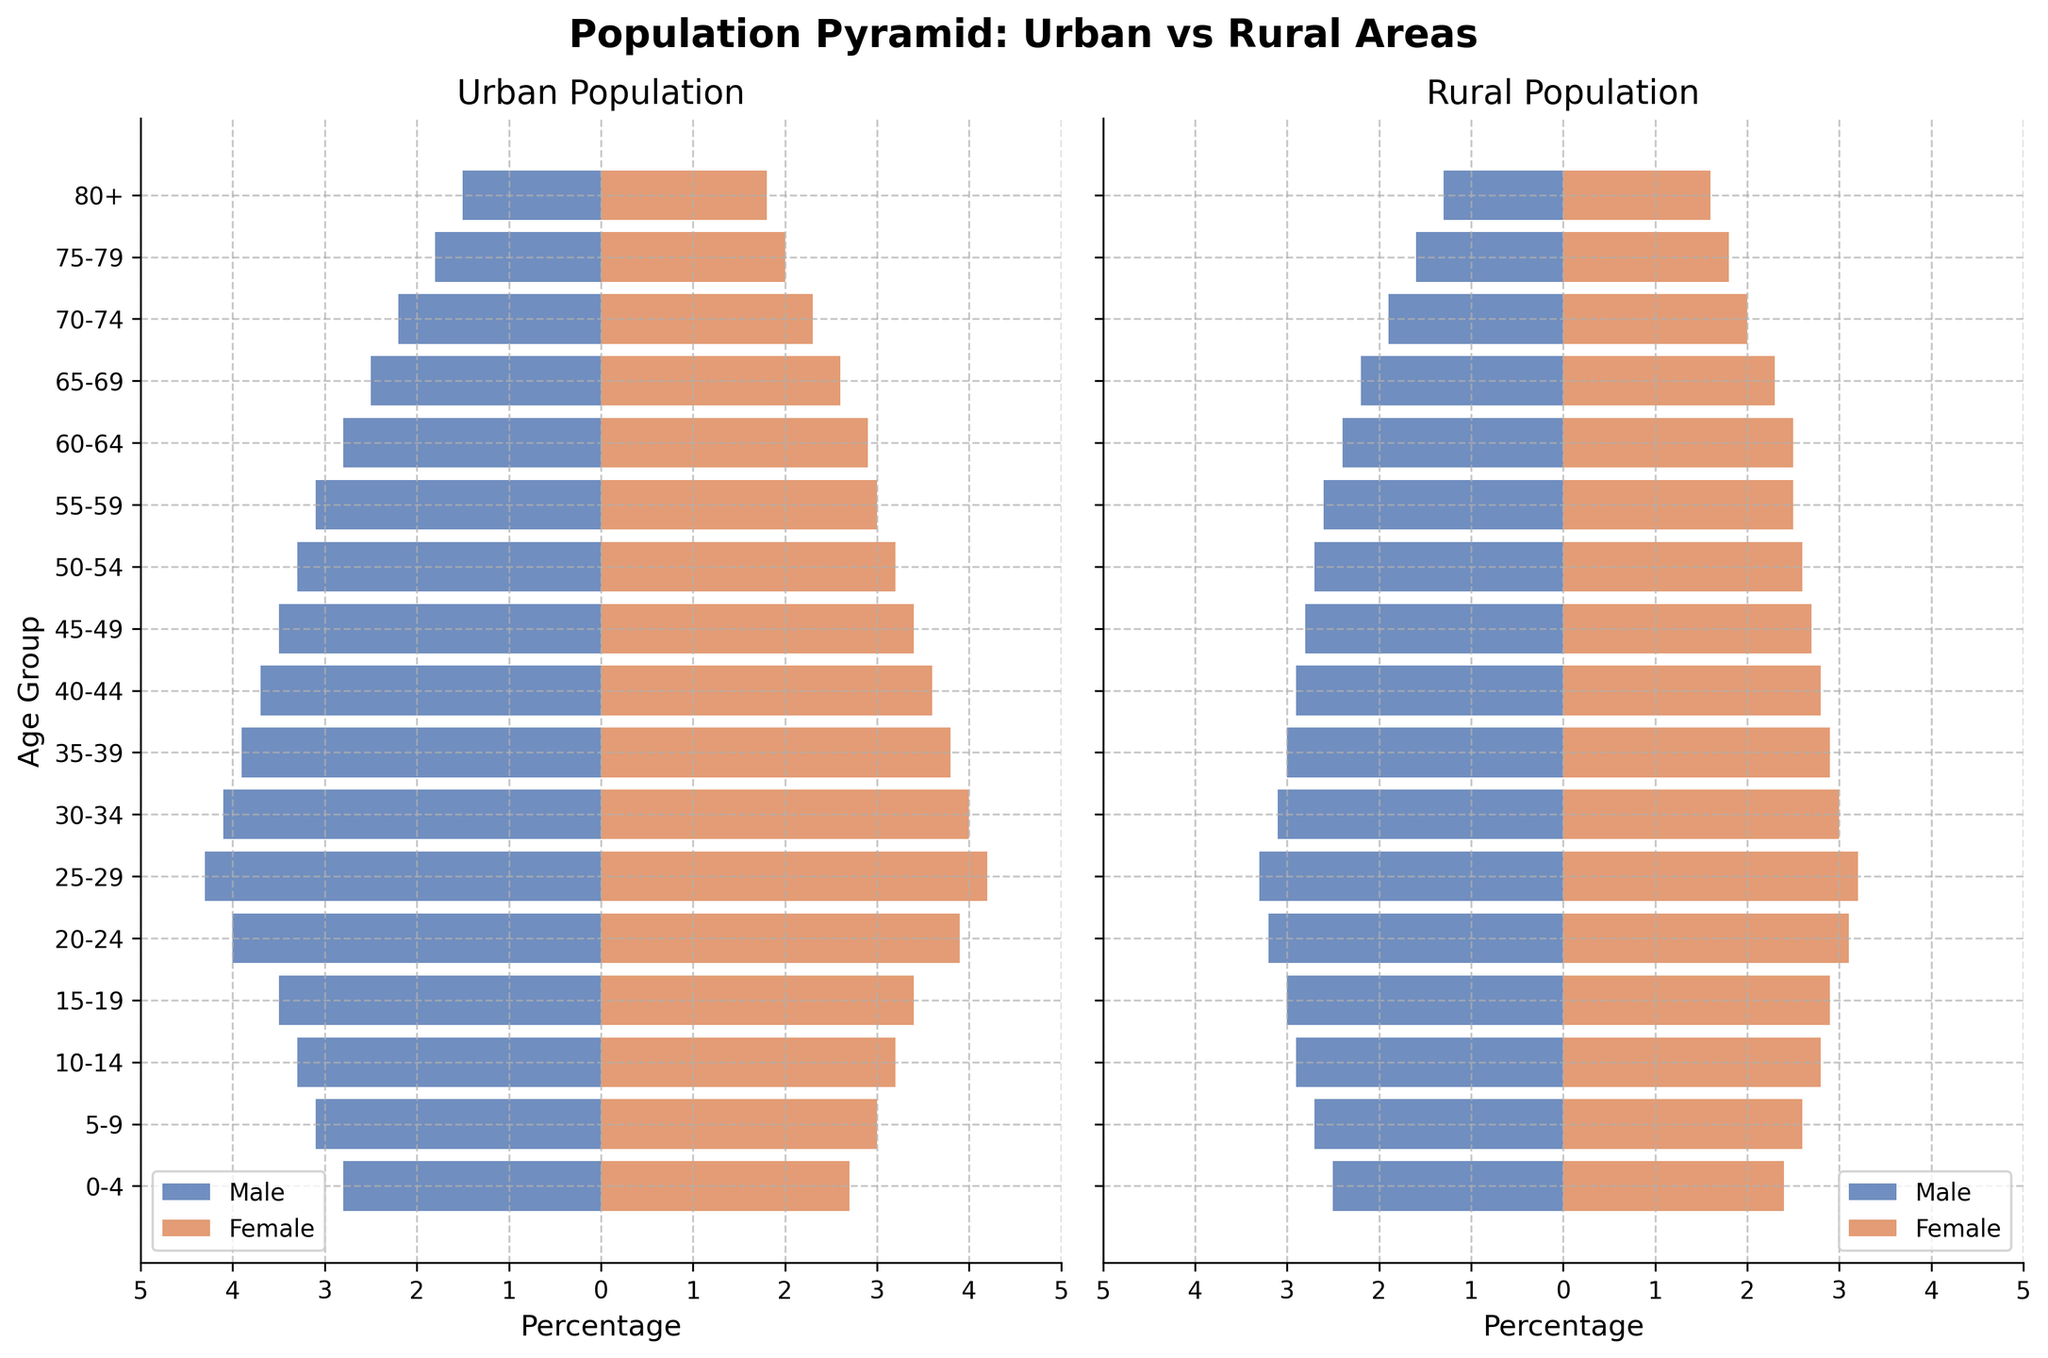What is the title of the figure? The title is usually prominently displayed at the top of a chart or plot. For this figure, it is located at the top and reads "Population Pyramid: Urban vs Rural Areas".
Answer: Population Pyramid: Urban vs Rural Areas How many age groups are displayed in the figure? To determine the number of age groups, count the labels on the vertical axis. In this case, there are labels from "0-4" to "80+", totaling 17 age group categories.
Answer: 17 What color represents urban males in the figure? We can identify the color by looking at the legend for urban males. The legend shows that urban males are represented by a blue bar.
Answer: Blue Which age group has the highest percentage of urban females? By examining the urban female bars on the left side of the chart, we see that the "25-29" age group has the largest bar length, indicating the highest percentage for urban females.
Answer: 25-29 What is the percentage difference between rural males and rural females in the 60-64 age group? First, identify the percentage for rural males (2.4%) and rural females (2.5%) in the 60-64 age group. The difference is 2.5 - 2.4 = 0.1%.
Answer: 0.1% Compare the age groups 75-79 and 80+ in terms of urban male population. Which group has a higher percentage? For urban males, the percentage bars for the "75-79" age group and "80+" age group are 1.8% and 1.5%, respectively. The "75-79" group has a higher percentage.
Answer: 75-79 In which age group is the rural male population almost equal to the rural female population? We look for the age group where the bars for rural males and females are almost the same length. The "60-64" age group shows a very close percentage, with rural males at 2.4% and rural females at 2.5%. The difference is minimal.
Answer: 60-64 Which population, urban or rural, shows a higher percentage for the 30-34 age group among males? Comparing the two bars for males aged 30-34, the urban male bar shows a percentage of 4.1%, while the rural male bar shows 3.1%. Therefore, the urban male percentage is higher.
Answer: Urban How do the percentages of males and females aged 20-24 compare in rural areas? In rural areas, the 20-24 age group has a male percentage of 3.2% and a female percentage of 3.1%. The percentage of males is slightly higher than that of females.
Answer: Males have a slightly higher percentage What is the pattern observed in the lower age groups (0-19) in urban compared to rural areas for both genders? For the age groups 0-4, 5-9, and 10-14, the urban area shows slightly higher percentages for both males and females compared to the rural areas. This pattern can be observed by comparing the lengths of the corresponding bars.
Answer: Urban shows slightly higher percentages 